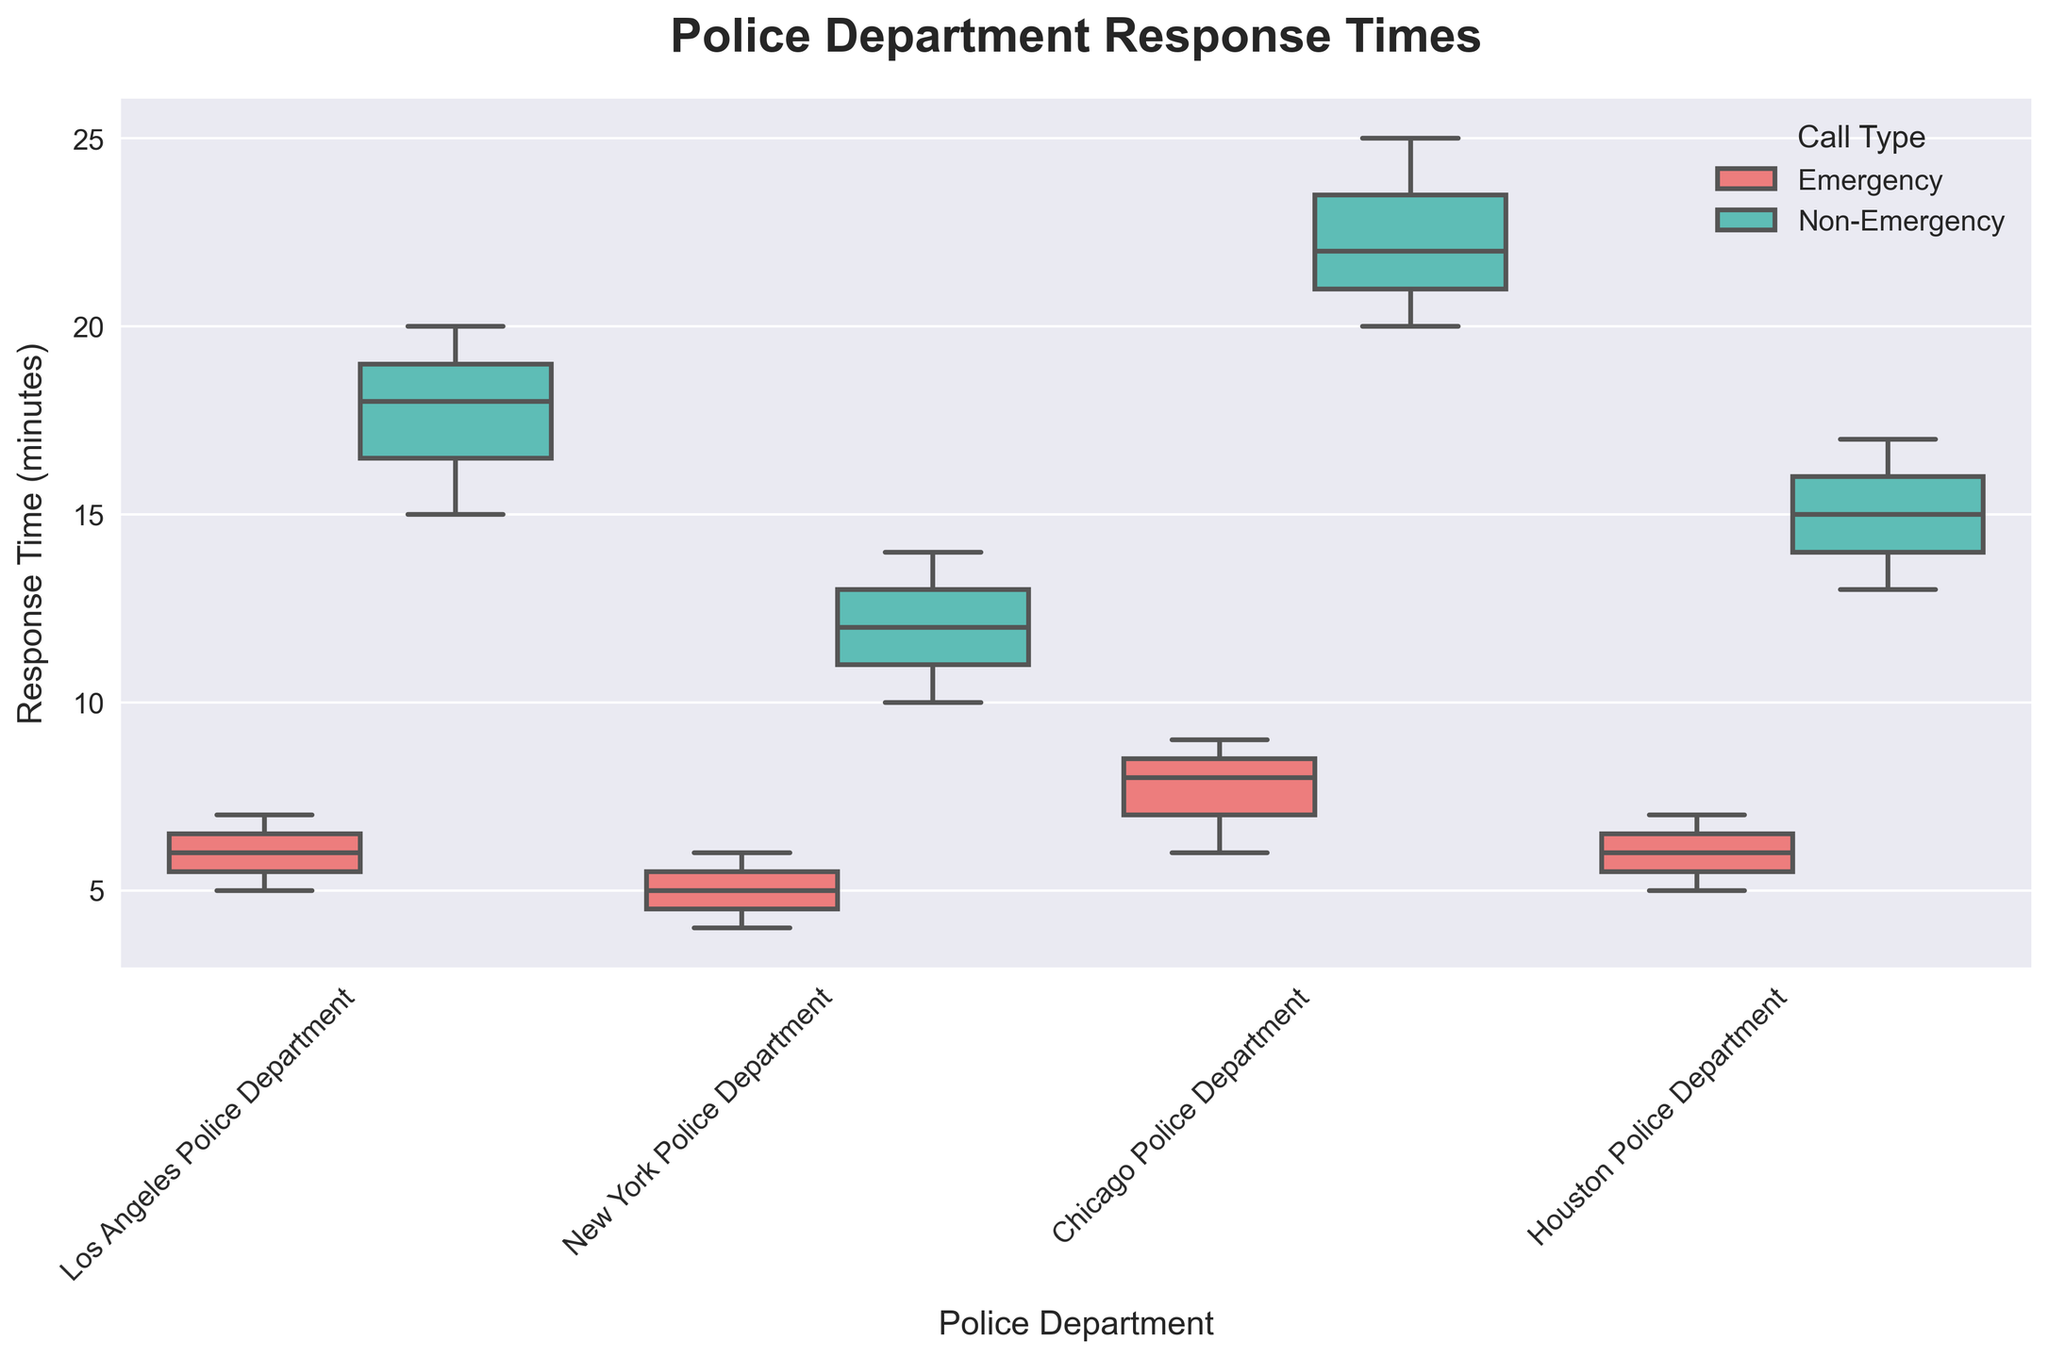What's the title of the plot? The title is usually located at the top of the plot and provides a summary of what the figure represents. In this case, the title is clearly indicated at the top of the plot.
Answer: Police Department Response Times What do the colors in the box plot represent? The legend at the upper right explains that the colors represent different call types. The red color corresponds to 'Emergency' calls, and the teal color corresponds to 'Non-Emergency' calls.
Answer: Call Types (Emergency and Non-Emergency) Which police department has the shortest median response time for emergency calls? By observing the central line within each box representing 'Emergency' calls, we can compare their positions. The New York Police Department has the shortest median line among the 'Emergency' group.
Answer: New York Police Department How does the variability of response times for non-emergency calls compare across departments? By observing the height of the boxes and the length of the whiskers, we can determine that variability. Chicago Police Department shows the greatest variability, with significant whisker lengths, while New York Police Department shows the smallest.
Answer: Chicago Police Department has the highest variability, New York Police Department the lowest What is the range of response times for the Los Angeles Police Department for non-emergency calls? The range is identified by the difference between the maximum and minimum whiskers for non-emergency calls for LAPD. The whiskers extend from 15 to 20 minutes.
Answer: 5 minutes Between which departments is the difference in median response times for emergency calls the greatest? We look at the central lines within each 'Emergency' box and measure the difference. The difference in medians is greatest between New York Police Department (shortest) and Chicago Police Department (longest).
Answer: New York Police Department and Chicago Police Department What is the interquartile range (IQR) of response times for the Houston Police Department for emergency calls? The IQR is the range of the box's top and bottom edges for emergency calls for the Houston Police Department. The box spans from 5 to 7 minutes.
Answer: 2 minutes Which department has a higher median response time for non-emergency calls than the median response time for emergency calls in any department? By observing the height of the medians for non-emergency groups against the emergency groups, Chicago Police Department’s non-emergency median response time overshadows the emergency medians of all departments.
Answer: Chicago Police Department Do any departments have outliers for non-emergency response times? Outliers are visible beyond the whiskers. In this grouped box plot, no outliers are visible for non-emergency calls since there are no points plotted outside the whiskers.
Answer: No 